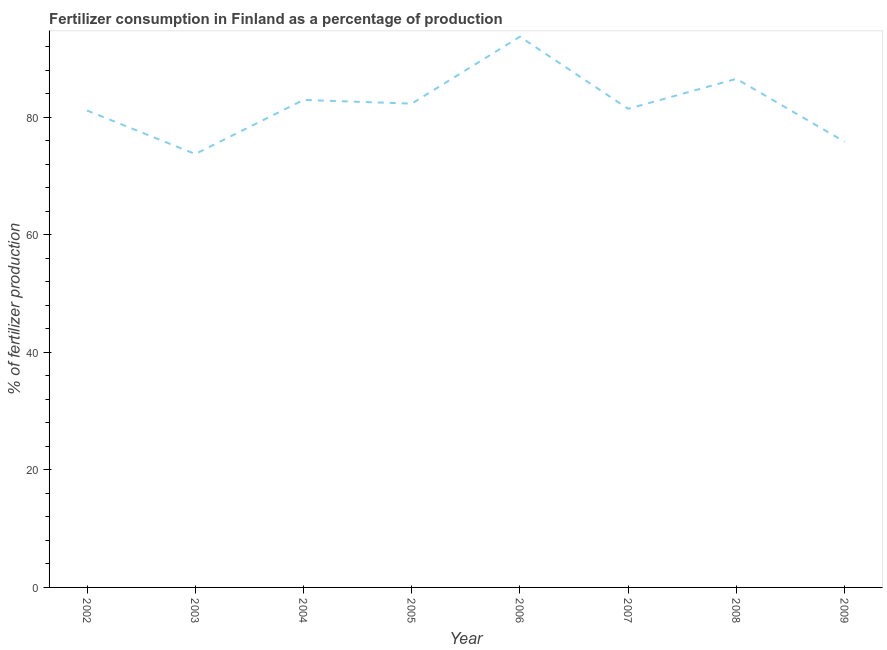What is the amount of fertilizer consumption in 2009?
Offer a terse response. 75.82. Across all years, what is the maximum amount of fertilizer consumption?
Your response must be concise. 93.69. Across all years, what is the minimum amount of fertilizer consumption?
Make the answer very short. 73.73. In which year was the amount of fertilizer consumption minimum?
Give a very brief answer. 2003. What is the sum of the amount of fertilizer consumption?
Keep it short and to the point. 657.56. What is the difference between the amount of fertilizer consumption in 2002 and 2009?
Your response must be concise. 5.32. What is the average amount of fertilizer consumption per year?
Your answer should be very brief. 82.19. What is the median amount of fertilizer consumption?
Your answer should be very brief. 81.86. What is the ratio of the amount of fertilizer consumption in 2004 to that in 2007?
Offer a very short reply. 1.02. Is the difference between the amount of fertilizer consumption in 2002 and 2007 greater than the difference between any two years?
Offer a terse response. No. What is the difference between the highest and the second highest amount of fertilizer consumption?
Your response must be concise. 7.17. Is the sum of the amount of fertilizer consumption in 2005 and 2008 greater than the maximum amount of fertilizer consumption across all years?
Offer a very short reply. Yes. What is the difference between the highest and the lowest amount of fertilizer consumption?
Give a very brief answer. 19.96. How many lines are there?
Provide a short and direct response. 1. How many years are there in the graph?
Your answer should be very brief. 8. Are the values on the major ticks of Y-axis written in scientific E-notation?
Ensure brevity in your answer.  No. What is the title of the graph?
Your response must be concise. Fertilizer consumption in Finland as a percentage of production. What is the label or title of the Y-axis?
Ensure brevity in your answer.  % of fertilizer production. What is the % of fertilizer production of 2002?
Your answer should be very brief. 81.14. What is the % of fertilizer production in 2003?
Your answer should be very brief. 73.73. What is the % of fertilizer production in 2004?
Provide a short and direct response. 82.93. What is the % of fertilizer production in 2005?
Provide a short and direct response. 82.3. What is the % of fertilizer production of 2006?
Offer a very short reply. 93.69. What is the % of fertilizer production of 2007?
Your answer should be compact. 81.42. What is the % of fertilizer production of 2008?
Give a very brief answer. 86.52. What is the % of fertilizer production of 2009?
Ensure brevity in your answer.  75.82. What is the difference between the % of fertilizer production in 2002 and 2003?
Provide a short and direct response. 7.41. What is the difference between the % of fertilizer production in 2002 and 2004?
Provide a succinct answer. -1.79. What is the difference between the % of fertilizer production in 2002 and 2005?
Provide a succinct answer. -1.17. What is the difference between the % of fertilizer production in 2002 and 2006?
Your answer should be compact. -12.55. What is the difference between the % of fertilizer production in 2002 and 2007?
Offer a terse response. -0.29. What is the difference between the % of fertilizer production in 2002 and 2008?
Give a very brief answer. -5.38. What is the difference between the % of fertilizer production in 2002 and 2009?
Your answer should be compact. 5.32. What is the difference between the % of fertilizer production in 2003 and 2004?
Your answer should be compact. -9.2. What is the difference between the % of fertilizer production in 2003 and 2005?
Offer a very short reply. -8.57. What is the difference between the % of fertilizer production in 2003 and 2006?
Keep it short and to the point. -19.96. What is the difference between the % of fertilizer production in 2003 and 2007?
Your response must be concise. -7.69. What is the difference between the % of fertilizer production in 2003 and 2008?
Your answer should be compact. -12.79. What is the difference between the % of fertilizer production in 2003 and 2009?
Your response must be concise. -2.09. What is the difference between the % of fertilizer production in 2004 and 2005?
Offer a terse response. 0.63. What is the difference between the % of fertilizer production in 2004 and 2006?
Offer a very short reply. -10.76. What is the difference between the % of fertilizer production in 2004 and 2007?
Keep it short and to the point. 1.51. What is the difference between the % of fertilizer production in 2004 and 2008?
Your answer should be compact. -3.59. What is the difference between the % of fertilizer production in 2004 and 2009?
Give a very brief answer. 7.11. What is the difference between the % of fertilizer production in 2005 and 2006?
Give a very brief answer. -11.39. What is the difference between the % of fertilizer production in 2005 and 2007?
Provide a short and direct response. 0.88. What is the difference between the % of fertilizer production in 2005 and 2008?
Offer a terse response. -4.22. What is the difference between the % of fertilizer production in 2005 and 2009?
Your response must be concise. 6.48. What is the difference between the % of fertilizer production in 2006 and 2007?
Make the answer very short. 12.27. What is the difference between the % of fertilizer production in 2006 and 2008?
Keep it short and to the point. 7.17. What is the difference between the % of fertilizer production in 2006 and 2009?
Give a very brief answer. 17.87. What is the difference between the % of fertilizer production in 2007 and 2008?
Ensure brevity in your answer.  -5.1. What is the difference between the % of fertilizer production in 2007 and 2009?
Ensure brevity in your answer.  5.6. What is the difference between the % of fertilizer production in 2008 and 2009?
Your answer should be very brief. 10.7. What is the ratio of the % of fertilizer production in 2002 to that in 2005?
Offer a very short reply. 0.99. What is the ratio of the % of fertilizer production in 2002 to that in 2006?
Provide a short and direct response. 0.87. What is the ratio of the % of fertilizer production in 2002 to that in 2007?
Offer a terse response. 1. What is the ratio of the % of fertilizer production in 2002 to that in 2008?
Your response must be concise. 0.94. What is the ratio of the % of fertilizer production in 2002 to that in 2009?
Make the answer very short. 1.07. What is the ratio of the % of fertilizer production in 2003 to that in 2004?
Provide a short and direct response. 0.89. What is the ratio of the % of fertilizer production in 2003 to that in 2005?
Your answer should be very brief. 0.9. What is the ratio of the % of fertilizer production in 2003 to that in 2006?
Your answer should be very brief. 0.79. What is the ratio of the % of fertilizer production in 2003 to that in 2007?
Your response must be concise. 0.91. What is the ratio of the % of fertilizer production in 2003 to that in 2008?
Make the answer very short. 0.85. What is the ratio of the % of fertilizer production in 2004 to that in 2006?
Ensure brevity in your answer.  0.89. What is the ratio of the % of fertilizer production in 2004 to that in 2008?
Your answer should be compact. 0.96. What is the ratio of the % of fertilizer production in 2004 to that in 2009?
Provide a short and direct response. 1.09. What is the ratio of the % of fertilizer production in 2005 to that in 2006?
Offer a terse response. 0.88. What is the ratio of the % of fertilizer production in 2005 to that in 2007?
Make the answer very short. 1.01. What is the ratio of the % of fertilizer production in 2005 to that in 2008?
Make the answer very short. 0.95. What is the ratio of the % of fertilizer production in 2005 to that in 2009?
Your answer should be compact. 1.09. What is the ratio of the % of fertilizer production in 2006 to that in 2007?
Your answer should be compact. 1.15. What is the ratio of the % of fertilizer production in 2006 to that in 2008?
Provide a succinct answer. 1.08. What is the ratio of the % of fertilizer production in 2006 to that in 2009?
Make the answer very short. 1.24. What is the ratio of the % of fertilizer production in 2007 to that in 2008?
Your answer should be compact. 0.94. What is the ratio of the % of fertilizer production in 2007 to that in 2009?
Provide a succinct answer. 1.07. What is the ratio of the % of fertilizer production in 2008 to that in 2009?
Provide a succinct answer. 1.14. 